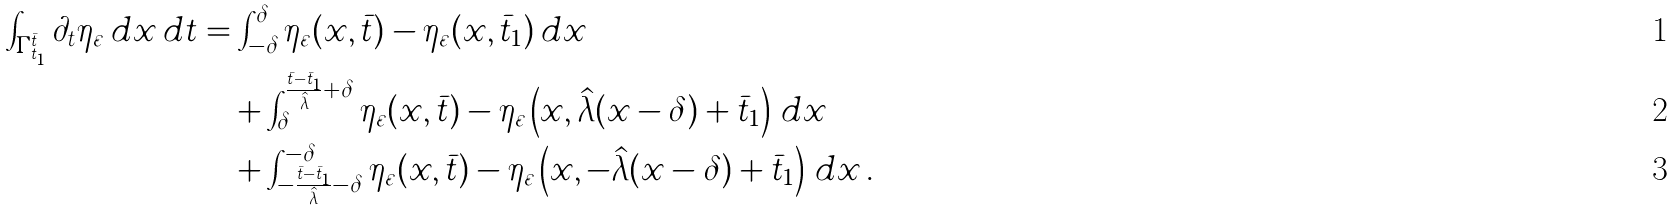<formula> <loc_0><loc_0><loc_500><loc_500>\int _ { \Gamma _ { t _ { 1 } } ^ { \bar { t } } } \partial _ { t } \eta _ { \varepsilon } \, d x \, d t & = \int _ { - \delta } ^ { \delta } \eta _ { \varepsilon } ( x , \bar { t } ) - \eta _ { \varepsilon } ( x , \bar { t } _ { 1 } ) \, d x \\ & \quad + \int _ { \delta } ^ { \frac { \bar { t } - \bar { t } _ { 1 } } { \hat { \lambda } } + \delta } \eta _ { \varepsilon } ( x , \bar { t } ) - \eta _ { \varepsilon } \left ( x , \hat { \lambda } ( x - \delta ) + \bar { t } _ { 1 } \right ) \, d x \\ & \quad + \int ^ { - \delta } _ { - \frac { \bar { t } - \bar { t } _ { 1 } } { \hat { \lambda } } - \delta } \eta _ { \varepsilon } ( x , \bar { t } ) - \eta _ { \varepsilon } \left ( x , - \hat { \lambda } ( x - \delta ) + \bar { t } _ { 1 } \right ) \, d x \, .</formula> 